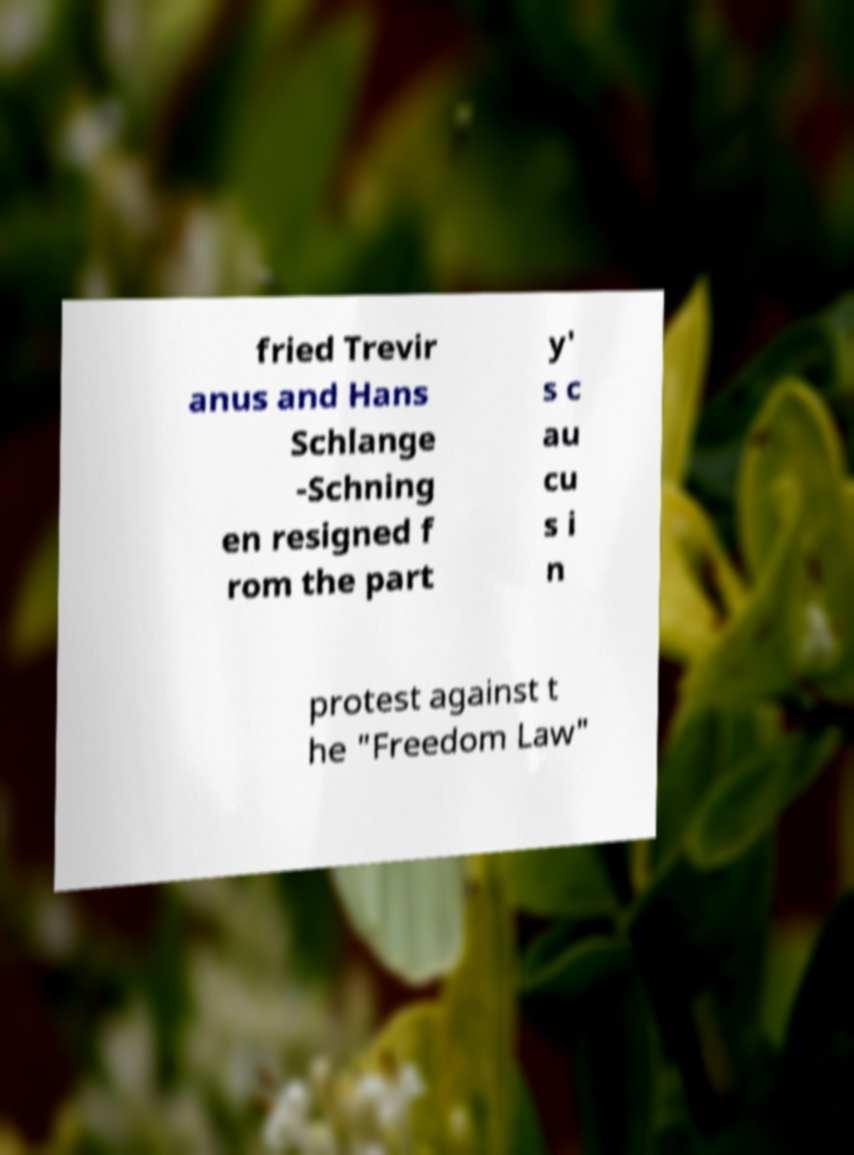Can you read and provide the text displayed in the image?This photo seems to have some interesting text. Can you extract and type it out for me? fried Trevir anus and Hans Schlange -Schning en resigned f rom the part y' s c au cu s i n protest against t he "Freedom Law" 